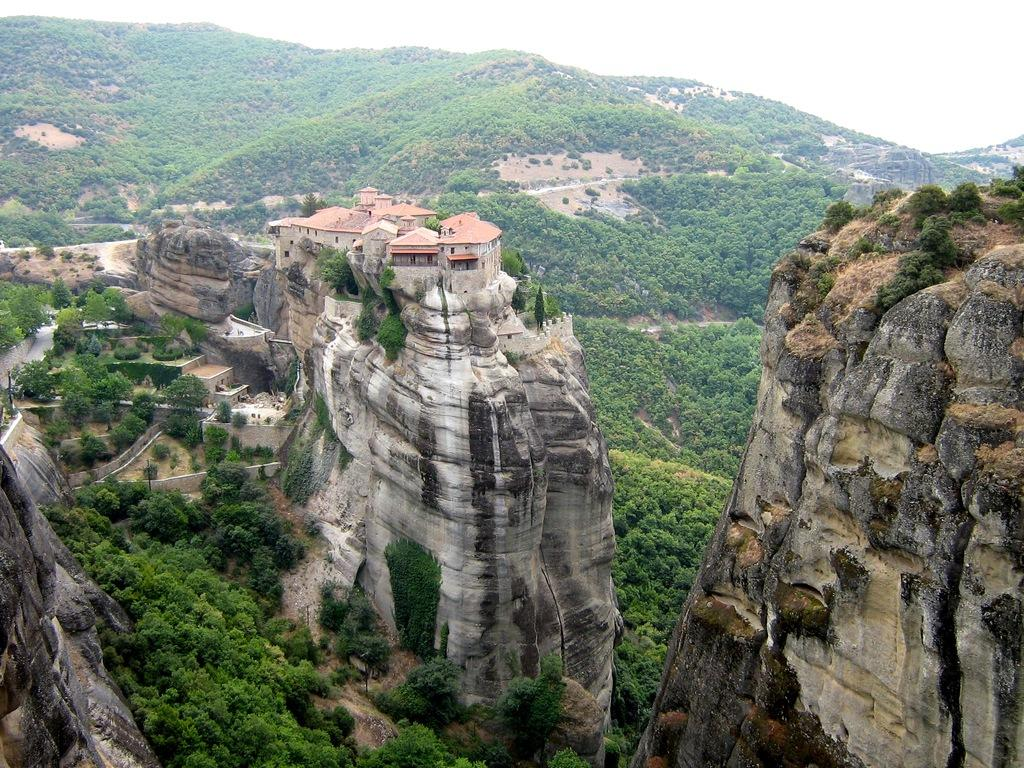What type of landscape is depicted in the image? The image features many hills. Are there any structures visible on the hills? Yes, there are houses on the hills. What other natural elements can be seen in the image? There are many trees in the image. How many friends are sitting on the floor in the image? There are no friends or floors present in the image; it features hills, houses, and trees. 